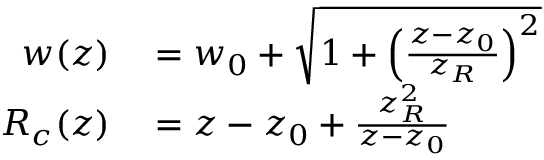Convert formula to latex. <formula><loc_0><loc_0><loc_500><loc_500>\begin{array} { r l } { w ( z ) } & = w _ { 0 } + \sqrt { 1 + \left ( \frac { z - z _ { 0 } } { z _ { R } } \right ) ^ { 2 } } } \\ { R _ { c } ( z ) } & = z - z _ { 0 } + \frac { z _ { R } ^ { 2 } } { z - z _ { 0 } } } \end{array}</formula> 